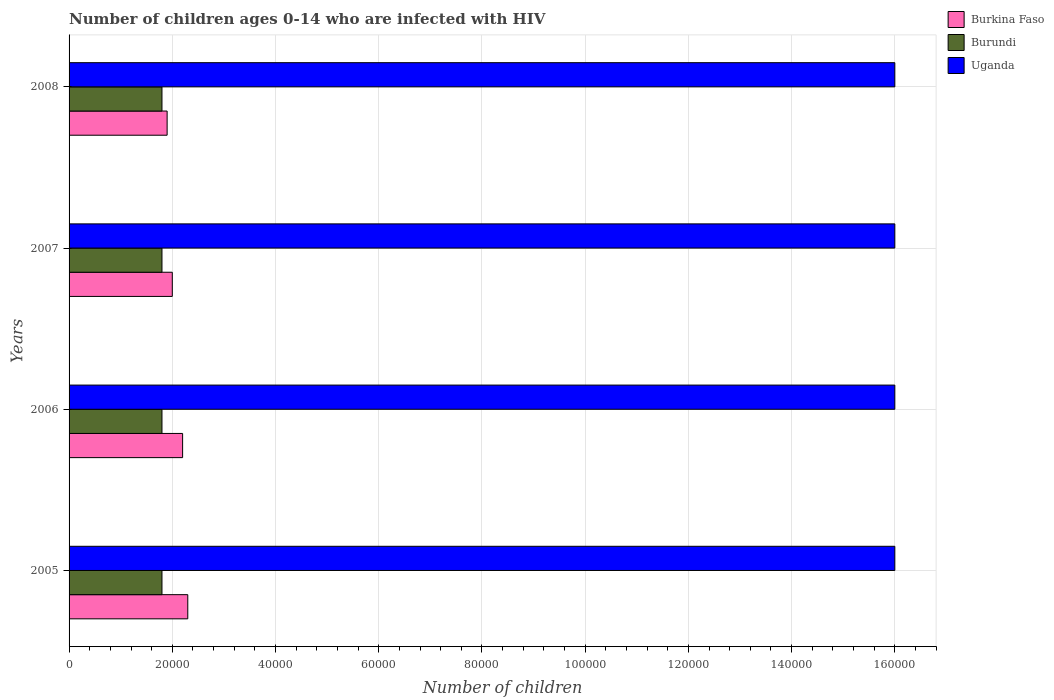What is the label of the 2nd group of bars from the top?
Your answer should be very brief. 2007. In how many cases, is the number of bars for a given year not equal to the number of legend labels?
Offer a very short reply. 0. What is the number of HIV infected children in Uganda in 2006?
Offer a terse response. 1.60e+05. Across all years, what is the maximum number of HIV infected children in Burundi?
Your answer should be very brief. 1.80e+04. Across all years, what is the minimum number of HIV infected children in Burundi?
Ensure brevity in your answer.  1.80e+04. In which year was the number of HIV infected children in Burkina Faso maximum?
Provide a short and direct response. 2005. What is the total number of HIV infected children in Burkina Faso in the graph?
Give a very brief answer. 8.40e+04. What is the difference between the number of HIV infected children in Burundi in 2006 and that in 2007?
Provide a succinct answer. 0. What is the difference between the number of HIV infected children in Uganda in 2005 and the number of HIV infected children in Burkina Faso in 2008?
Your answer should be very brief. 1.41e+05. What is the average number of HIV infected children in Burkina Faso per year?
Ensure brevity in your answer.  2.10e+04. In the year 2005, what is the difference between the number of HIV infected children in Uganda and number of HIV infected children in Burkina Faso?
Keep it short and to the point. 1.37e+05. In how many years, is the number of HIV infected children in Burundi greater than 40000 ?
Offer a terse response. 0. What is the ratio of the number of HIV infected children in Burkina Faso in 2005 to that in 2007?
Give a very brief answer. 1.15. What is the difference between the highest and the second highest number of HIV infected children in Burkina Faso?
Your response must be concise. 1000. What is the difference between the highest and the lowest number of HIV infected children in Burkina Faso?
Keep it short and to the point. 4000. Is the sum of the number of HIV infected children in Burkina Faso in 2006 and 2008 greater than the maximum number of HIV infected children in Uganda across all years?
Provide a short and direct response. No. What does the 3rd bar from the top in 2008 represents?
Ensure brevity in your answer.  Burkina Faso. What does the 2nd bar from the bottom in 2006 represents?
Keep it short and to the point. Burundi. Are all the bars in the graph horizontal?
Offer a very short reply. Yes. How many years are there in the graph?
Your answer should be very brief. 4. What is the difference between two consecutive major ticks on the X-axis?
Keep it short and to the point. 2.00e+04. Does the graph contain any zero values?
Ensure brevity in your answer.  No. Does the graph contain grids?
Your response must be concise. Yes. How are the legend labels stacked?
Give a very brief answer. Vertical. What is the title of the graph?
Offer a terse response. Number of children ages 0-14 who are infected with HIV. What is the label or title of the X-axis?
Make the answer very short. Number of children. What is the label or title of the Y-axis?
Make the answer very short. Years. What is the Number of children in Burkina Faso in 2005?
Keep it short and to the point. 2.30e+04. What is the Number of children in Burundi in 2005?
Your answer should be compact. 1.80e+04. What is the Number of children in Uganda in 2005?
Your answer should be very brief. 1.60e+05. What is the Number of children of Burkina Faso in 2006?
Provide a short and direct response. 2.20e+04. What is the Number of children in Burundi in 2006?
Ensure brevity in your answer.  1.80e+04. What is the Number of children of Uganda in 2006?
Your answer should be compact. 1.60e+05. What is the Number of children of Burundi in 2007?
Provide a short and direct response. 1.80e+04. What is the Number of children in Burkina Faso in 2008?
Make the answer very short. 1.90e+04. What is the Number of children of Burundi in 2008?
Your answer should be very brief. 1.80e+04. What is the Number of children of Uganda in 2008?
Your answer should be compact. 1.60e+05. Across all years, what is the maximum Number of children in Burkina Faso?
Offer a very short reply. 2.30e+04. Across all years, what is the maximum Number of children in Burundi?
Keep it short and to the point. 1.80e+04. Across all years, what is the minimum Number of children in Burkina Faso?
Your answer should be very brief. 1.90e+04. Across all years, what is the minimum Number of children of Burundi?
Offer a very short reply. 1.80e+04. What is the total Number of children in Burkina Faso in the graph?
Your response must be concise. 8.40e+04. What is the total Number of children in Burundi in the graph?
Make the answer very short. 7.20e+04. What is the total Number of children in Uganda in the graph?
Provide a short and direct response. 6.40e+05. What is the difference between the Number of children in Burundi in 2005 and that in 2006?
Give a very brief answer. 0. What is the difference between the Number of children of Uganda in 2005 and that in 2006?
Your answer should be compact. 0. What is the difference between the Number of children in Burkina Faso in 2005 and that in 2007?
Provide a short and direct response. 3000. What is the difference between the Number of children of Uganda in 2005 and that in 2007?
Your response must be concise. 0. What is the difference between the Number of children of Burkina Faso in 2005 and that in 2008?
Your response must be concise. 4000. What is the difference between the Number of children in Burundi in 2005 and that in 2008?
Offer a terse response. 0. What is the difference between the Number of children of Burkina Faso in 2006 and that in 2007?
Offer a very short reply. 2000. What is the difference between the Number of children of Burundi in 2006 and that in 2007?
Provide a succinct answer. 0. What is the difference between the Number of children in Burkina Faso in 2006 and that in 2008?
Offer a very short reply. 3000. What is the difference between the Number of children in Burundi in 2006 and that in 2008?
Make the answer very short. 0. What is the difference between the Number of children of Uganda in 2007 and that in 2008?
Make the answer very short. 0. What is the difference between the Number of children in Burkina Faso in 2005 and the Number of children in Burundi in 2006?
Your answer should be very brief. 5000. What is the difference between the Number of children of Burkina Faso in 2005 and the Number of children of Uganda in 2006?
Give a very brief answer. -1.37e+05. What is the difference between the Number of children of Burundi in 2005 and the Number of children of Uganda in 2006?
Make the answer very short. -1.42e+05. What is the difference between the Number of children in Burkina Faso in 2005 and the Number of children in Uganda in 2007?
Your response must be concise. -1.37e+05. What is the difference between the Number of children of Burundi in 2005 and the Number of children of Uganda in 2007?
Offer a terse response. -1.42e+05. What is the difference between the Number of children of Burkina Faso in 2005 and the Number of children of Burundi in 2008?
Make the answer very short. 5000. What is the difference between the Number of children in Burkina Faso in 2005 and the Number of children in Uganda in 2008?
Your answer should be compact. -1.37e+05. What is the difference between the Number of children of Burundi in 2005 and the Number of children of Uganda in 2008?
Your answer should be very brief. -1.42e+05. What is the difference between the Number of children of Burkina Faso in 2006 and the Number of children of Burundi in 2007?
Make the answer very short. 4000. What is the difference between the Number of children in Burkina Faso in 2006 and the Number of children in Uganda in 2007?
Give a very brief answer. -1.38e+05. What is the difference between the Number of children of Burundi in 2006 and the Number of children of Uganda in 2007?
Your response must be concise. -1.42e+05. What is the difference between the Number of children in Burkina Faso in 2006 and the Number of children in Burundi in 2008?
Your response must be concise. 4000. What is the difference between the Number of children in Burkina Faso in 2006 and the Number of children in Uganda in 2008?
Provide a succinct answer. -1.38e+05. What is the difference between the Number of children in Burundi in 2006 and the Number of children in Uganda in 2008?
Provide a short and direct response. -1.42e+05. What is the difference between the Number of children in Burundi in 2007 and the Number of children in Uganda in 2008?
Offer a very short reply. -1.42e+05. What is the average Number of children of Burkina Faso per year?
Keep it short and to the point. 2.10e+04. What is the average Number of children in Burundi per year?
Provide a short and direct response. 1.80e+04. In the year 2005, what is the difference between the Number of children in Burkina Faso and Number of children in Burundi?
Make the answer very short. 5000. In the year 2005, what is the difference between the Number of children of Burkina Faso and Number of children of Uganda?
Give a very brief answer. -1.37e+05. In the year 2005, what is the difference between the Number of children of Burundi and Number of children of Uganda?
Your answer should be compact. -1.42e+05. In the year 2006, what is the difference between the Number of children in Burkina Faso and Number of children in Burundi?
Provide a short and direct response. 4000. In the year 2006, what is the difference between the Number of children of Burkina Faso and Number of children of Uganda?
Provide a short and direct response. -1.38e+05. In the year 2006, what is the difference between the Number of children of Burundi and Number of children of Uganda?
Ensure brevity in your answer.  -1.42e+05. In the year 2007, what is the difference between the Number of children in Burkina Faso and Number of children in Uganda?
Offer a very short reply. -1.40e+05. In the year 2007, what is the difference between the Number of children of Burundi and Number of children of Uganda?
Provide a succinct answer. -1.42e+05. In the year 2008, what is the difference between the Number of children in Burkina Faso and Number of children in Burundi?
Your answer should be compact. 1000. In the year 2008, what is the difference between the Number of children in Burkina Faso and Number of children in Uganda?
Your response must be concise. -1.41e+05. In the year 2008, what is the difference between the Number of children in Burundi and Number of children in Uganda?
Your answer should be compact. -1.42e+05. What is the ratio of the Number of children in Burkina Faso in 2005 to that in 2006?
Make the answer very short. 1.05. What is the ratio of the Number of children in Burundi in 2005 to that in 2006?
Give a very brief answer. 1. What is the ratio of the Number of children of Burkina Faso in 2005 to that in 2007?
Provide a short and direct response. 1.15. What is the ratio of the Number of children in Burkina Faso in 2005 to that in 2008?
Your answer should be compact. 1.21. What is the ratio of the Number of children in Uganda in 2005 to that in 2008?
Offer a terse response. 1. What is the ratio of the Number of children in Burkina Faso in 2006 to that in 2007?
Your answer should be very brief. 1.1. What is the ratio of the Number of children in Uganda in 2006 to that in 2007?
Your response must be concise. 1. What is the ratio of the Number of children of Burkina Faso in 2006 to that in 2008?
Your response must be concise. 1.16. What is the ratio of the Number of children of Burkina Faso in 2007 to that in 2008?
Offer a very short reply. 1.05. What is the ratio of the Number of children in Burundi in 2007 to that in 2008?
Ensure brevity in your answer.  1. What is the ratio of the Number of children in Uganda in 2007 to that in 2008?
Your answer should be very brief. 1. What is the difference between the highest and the second highest Number of children in Burkina Faso?
Ensure brevity in your answer.  1000. What is the difference between the highest and the second highest Number of children of Burundi?
Your response must be concise. 0. What is the difference between the highest and the second highest Number of children of Uganda?
Ensure brevity in your answer.  0. What is the difference between the highest and the lowest Number of children in Burkina Faso?
Make the answer very short. 4000. What is the difference between the highest and the lowest Number of children of Burundi?
Provide a succinct answer. 0. What is the difference between the highest and the lowest Number of children in Uganda?
Keep it short and to the point. 0. 